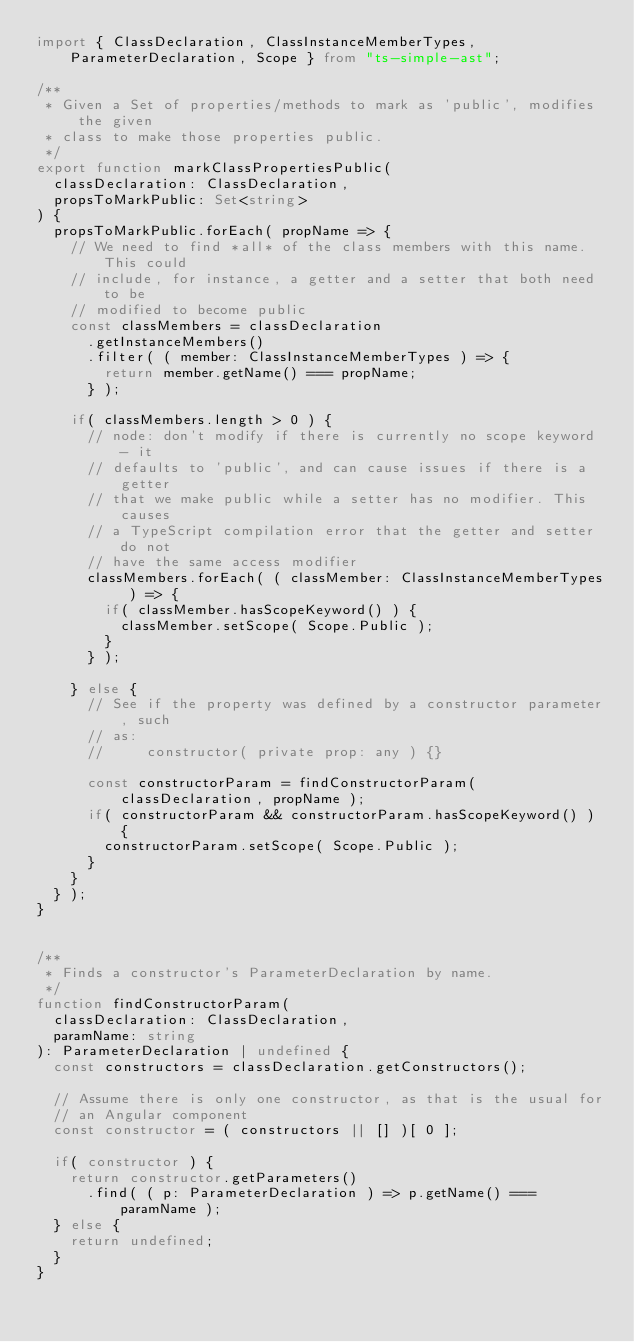Convert code to text. <code><loc_0><loc_0><loc_500><loc_500><_TypeScript_>import { ClassDeclaration, ClassInstanceMemberTypes, ParameterDeclaration, Scope } from "ts-simple-ast";

/**
 * Given a Set of properties/methods to mark as 'public', modifies the given
 * class to make those properties public.
 */
export function markClassPropertiesPublic(
	classDeclaration: ClassDeclaration,
	propsToMarkPublic: Set<string>
) {
	propsToMarkPublic.forEach( propName => {
		// We need to find *all* of the class members with this name. This could
		// include, for instance, a getter and a setter that both need to be
		// modified to become public
		const classMembers = classDeclaration
			.getInstanceMembers()
			.filter( ( member: ClassInstanceMemberTypes ) => {
				return member.getName() === propName;
			} );

		if( classMembers.length > 0 ) {
			// node: don't modify if there is currently no scope keyword - it
			// defaults to 'public', and can cause issues if there is a getter
			// that we make public while a setter has no modifier. This causes
			// a TypeScript compilation error that the getter and setter do not
			// have the same access modifier
			classMembers.forEach( ( classMember: ClassInstanceMemberTypes ) => {
				if( classMember.hasScopeKeyword() ) {
					classMember.setScope( Scope.Public );
				}
			} );

		} else {
			// See if the property was defined by a constructor parameter, such
			// as:
			//     constructor( private prop: any ) {}

			const constructorParam = findConstructorParam( classDeclaration, propName );
			if( constructorParam && constructorParam.hasScopeKeyword() ) {
				constructorParam.setScope( Scope.Public );
			}
		}
	} );
}


/**
 * Finds a constructor's ParameterDeclaration by name.
 */
function findConstructorParam(
	classDeclaration: ClassDeclaration,
	paramName: string
): ParameterDeclaration | undefined {
	const constructors = classDeclaration.getConstructors();

	// Assume there is only one constructor, as that is the usual for
	// an Angular component
	const constructor = ( constructors || [] )[ 0 ];

	if( constructor ) {
		return constructor.getParameters()
			.find( ( p: ParameterDeclaration ) => p.getName() === paramName );
	} else {
		return undefined;
	}
}</code> 